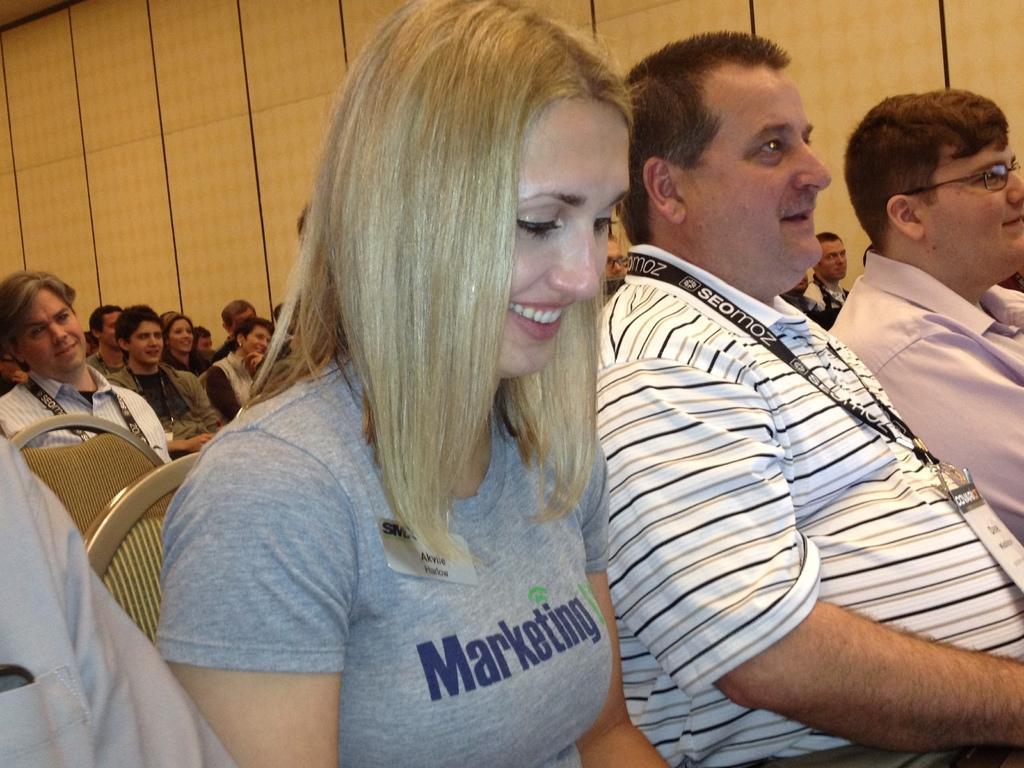How would you summarize this image in a sentence or two? In this image I can see group of people sitting on the chairs, the person in front wearing gray color dress. Background I can see wall in brown color. 